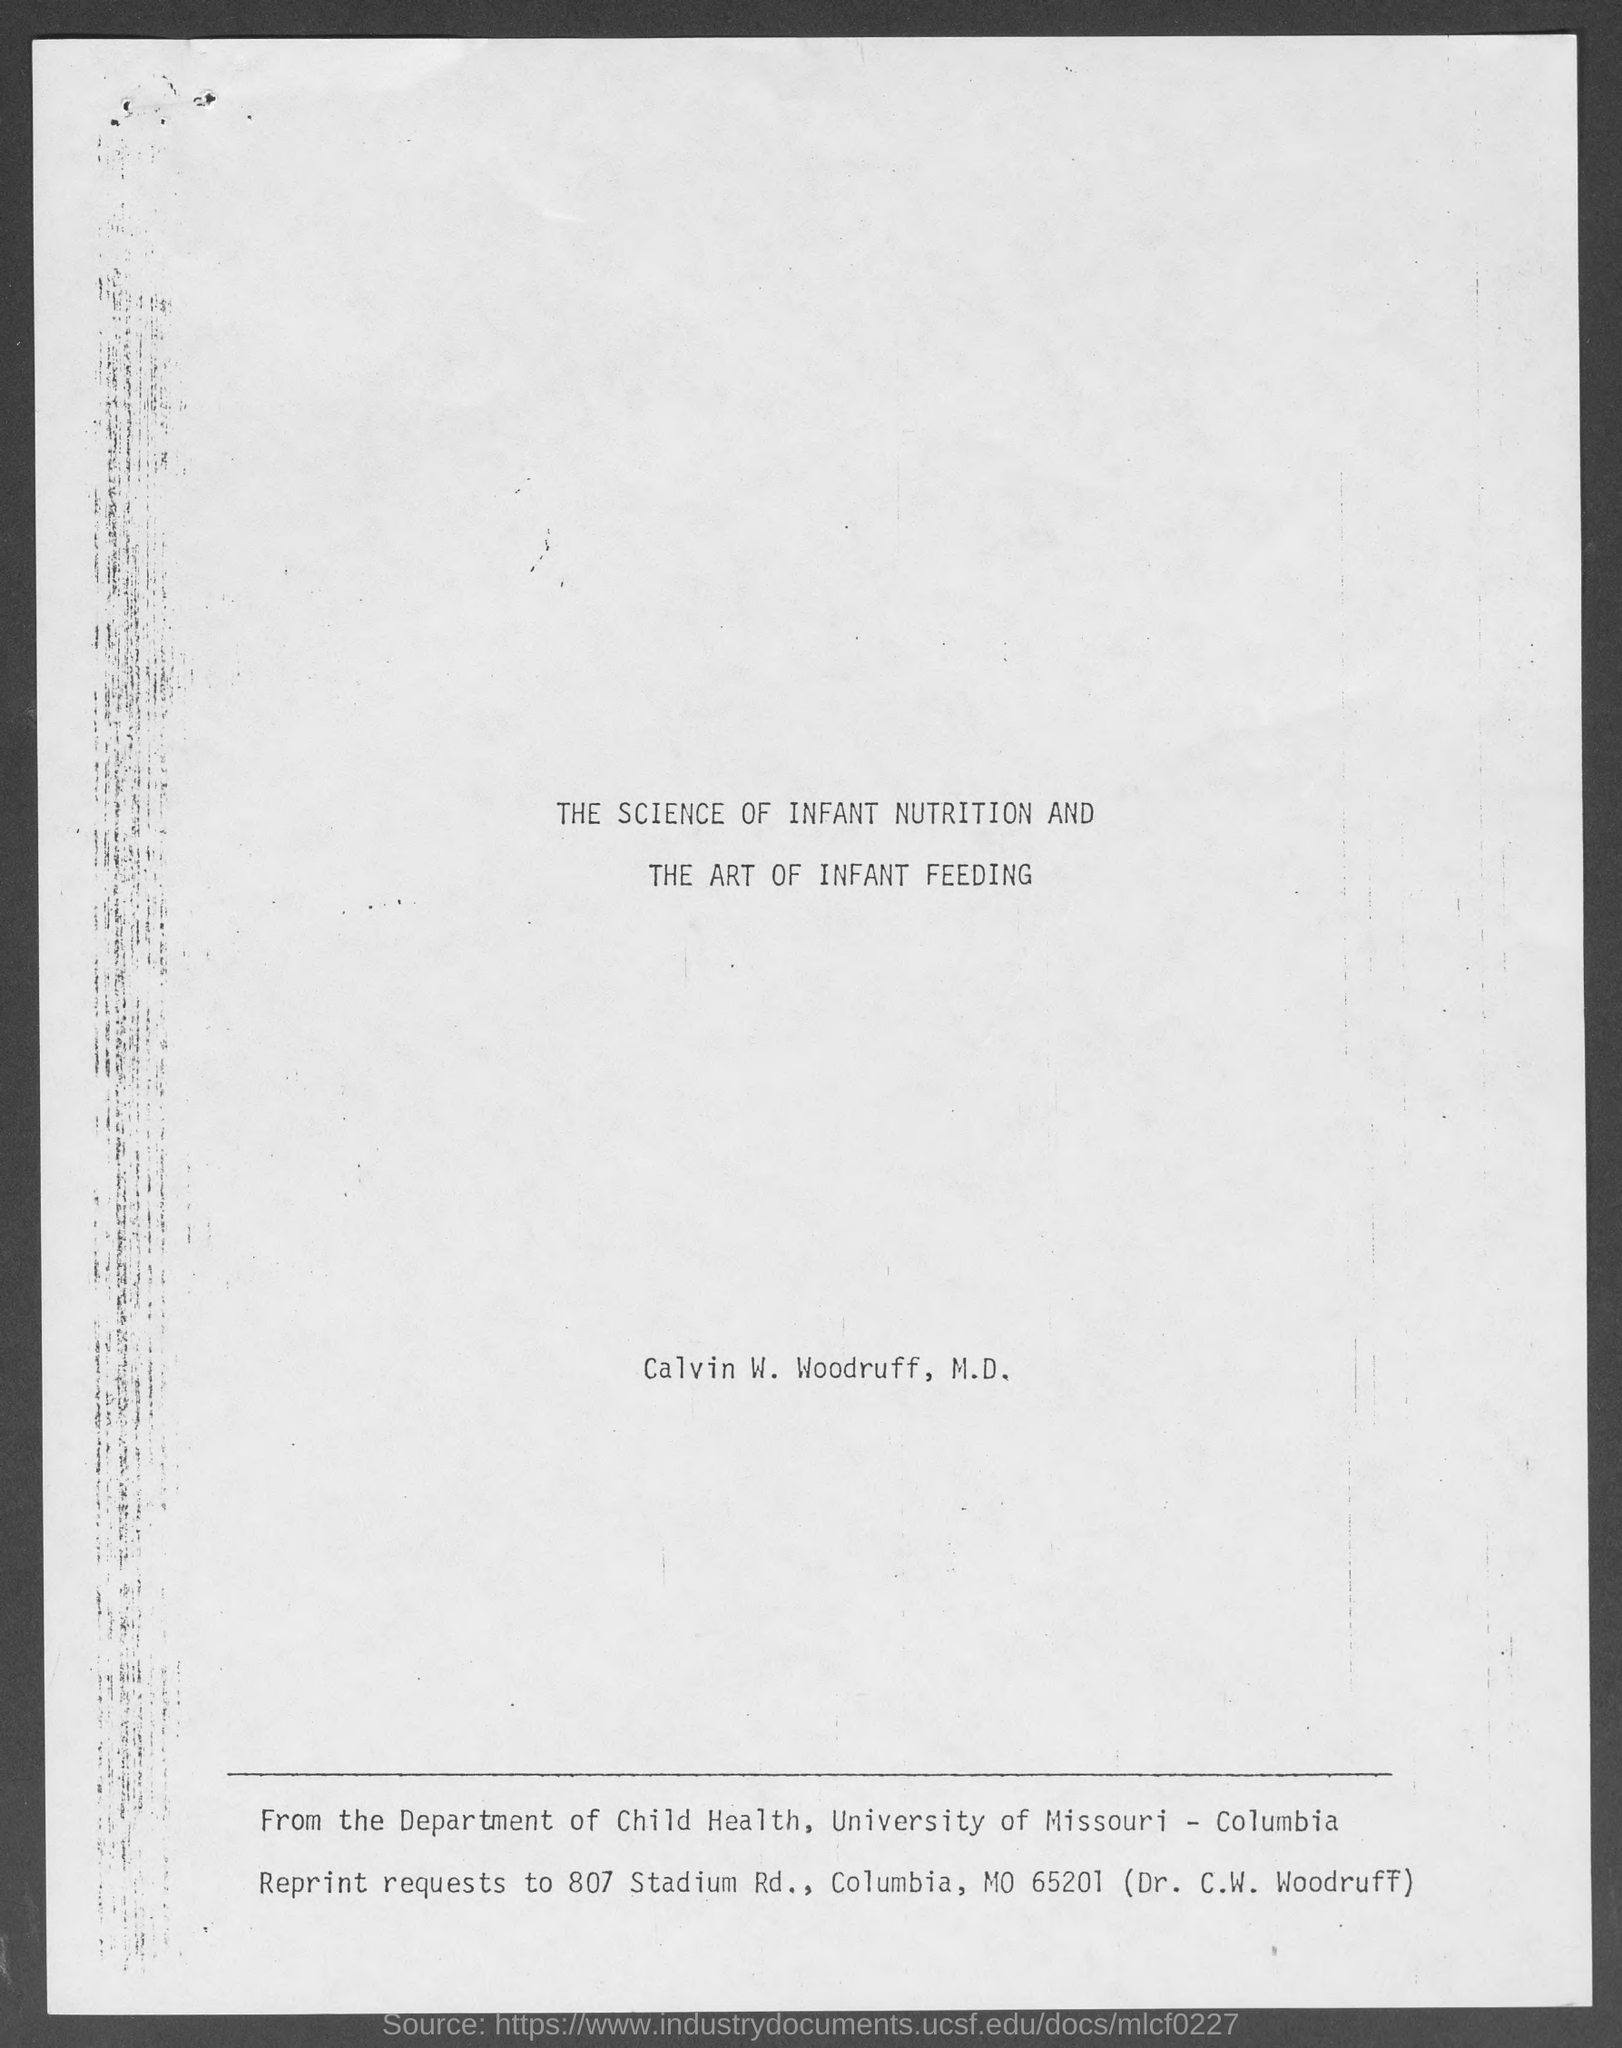Which is the department mentioned?
Your answer should be compact. Department of child health. Whose name is written on the document?
Your answer should be compact. Calvin w. woodruff, m.d. 